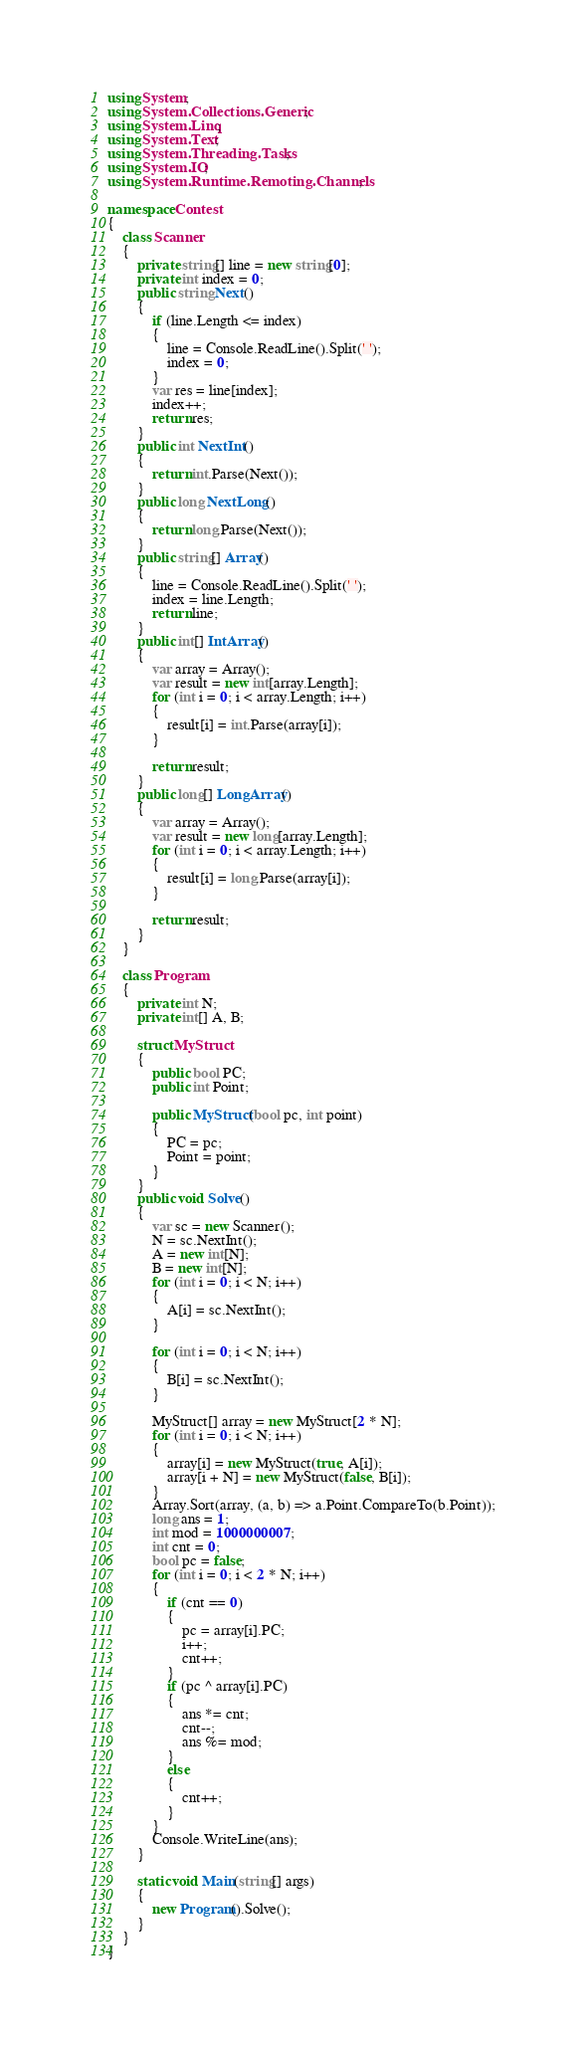Convert code to text. <code><loc_0><loc_0><loc_500><loc_500><_C#_>using System;
using System.Collections.Generic;
using System.Linq;
using System.Text;
using System.Threading.Tasks;
using System.IO;
using System.Runtime.Remoting.Channels;

namespace Contest
{
    class Scanner
    {
        private string[] line = new string[0];
        private int index = 0;
        public string Next()
        {
            if (line.Length <= index)
            {
                line = Console.ReadLine().Split(' ');
                index = 0;
            }
            var res = line[index];
            index++;
            return res;
        }
        public int NextInt()
        {
            return int.Parse(Next());
        }
        public long NextLong()
        {
            return long.Parse(Next());
        }
        public string[] Array()
        {
            line = Console.ReadLine().Split(' ');
            index = line.Length;
            return line;
        }
        public int[] IntArray()
        {
            var array = Array();
            var result = new int[array.Length];
            for (int i = 0; i < array.Length; i++)
            {
                result[i] = int.Parse(array[i]);
            }

            return result;
        }
        public long[] LongArray()
        {
            var array = Array();
            var result = new long[array.Length];
            for (int i = 0; i < array.Length; i++)
            {
                result[i] = long.Parse(array[i]);
            }

            return result;
        }
    }

    class Program
    {
        private int N;
        private int[] A, B;

        struct MyStruct
        {
            public bool PC;
            public int Point;

            public MyStruct(bool pc, int point)
            {
                PC = pc;
                Point = point;
            }
        }
        public void Solve()
        {
            var sc = new Scanner();
            N = sc.NextInt();
            A = new int[N];
            B = new int[N];
            for (int i = 0; i < N; i++)
            {
                A[i] = sc.NextInt();
            }

            for (int i = 0; i < N; i++)
            {
                B[i] = sc.NextInt();
            }

            MyStruct[] array = new MyStruct[2 * N];
            for (int i = 0; i < N; i++)
            {
                array[i] = new MyStruct(true, A[i]);
                array[i + N] = new MyStruct(false, B[i]);
            }
            Array.Sort(array, (a, b) => a.Point.CompareTo(b.Point));
            long ans = 1;
            int mod = 1000000007;
            int cnt = 0;
            bool pc = false;
            for (int i = 0; i < 2 * N; i++)
            {
                if (cnt == 0)
                {
                    pc = array[i].PC;
                    i++;
                    cnt++;
                }
                if (pc ^ array[i].PC)
                {
                    ans *= cnt;
                    cnt--;
                    ans %= mod;
                }
                else
                {
                    cnt++;
                }
            }
            Console.WriteLine(ans);
        }

        static void Main(string[] args)
        {
            new Program().Solve();
        }
    }
}</code> 